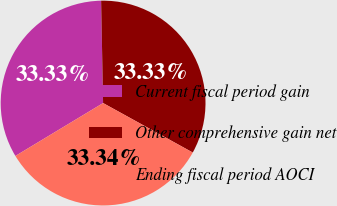<chart> <loc_0><loc_0><loc_500><loc_500><pie_chart><fcel>Current fiscal period gain<fcel>Other comprehensive gain net<fcel>Ending fiscal period AOCI<nl><fcel>33.33%<fcel>33.33%<fcel>33.34%<nl></chart> 